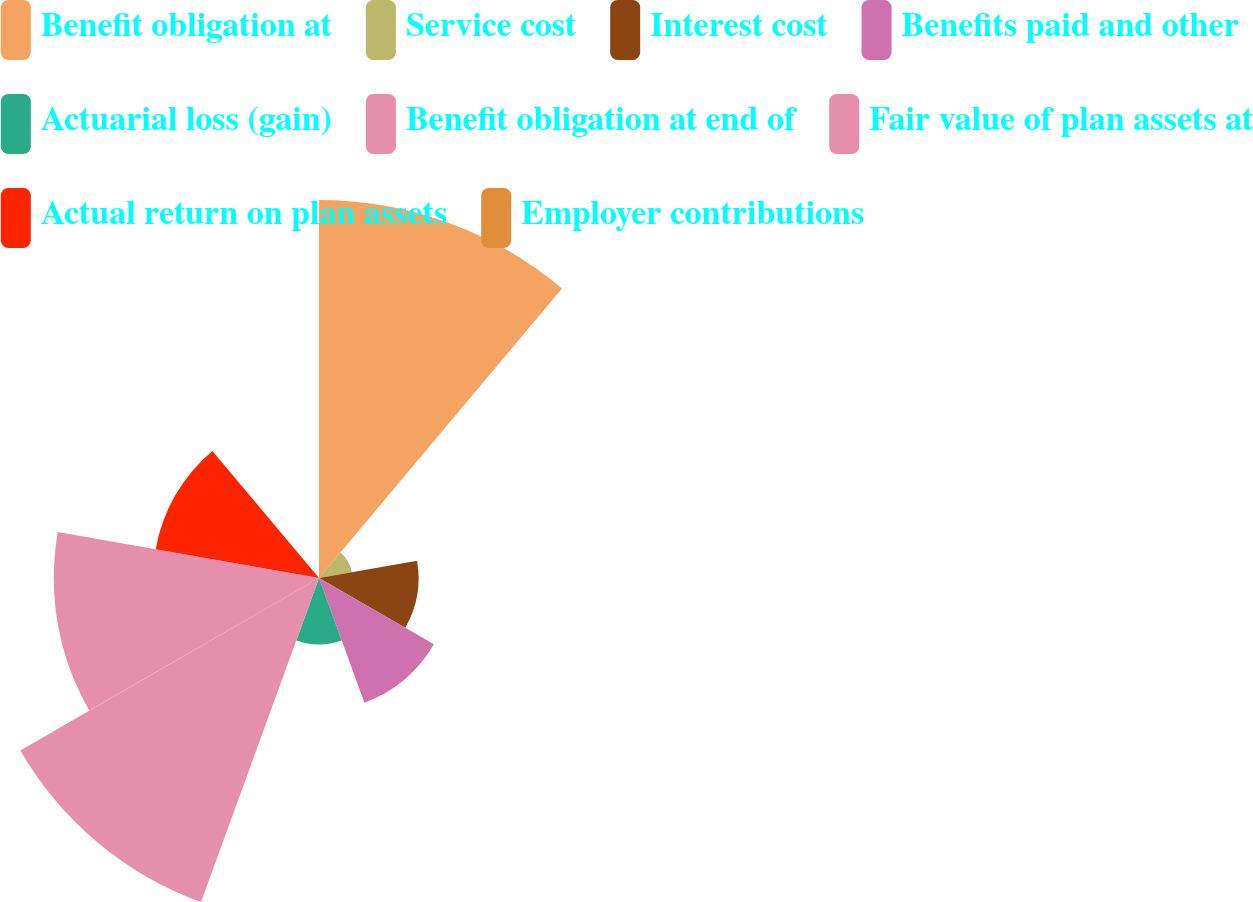Convert chart to OTSL. <chart><loc_0><loc_0><loc_500><loc_500><pie_chart><fcel>Benefit obligation at<fcel>Service cost<fcel>Interest cost<fcel>Benefits paid and other<fcel>Actuarial loss (gain)<fcel>Benefit obligation at end of<fcel>Fair value of plan assets at<fcel>Actual return on plan assets<fcel>Employer contributions<nl><fcel>25.44%<fcel>2.24%<fcel>6.7%<fcel>8.93%<fcel>4.47%<fcel>23.21%<fcel>17.85%<fcel>11.16%<fcel>0.01%<nl></chart> 